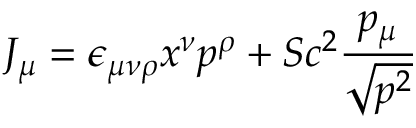Convert formula to latex. <formula><loc_0><loc_0><loc_500><loc_500>J _ { \mu } = \epsilon _ { \mu \nu \rho } x ^ { \nu } p ^ { \rho } + S c ^ { 2 } \frac { p _ { \mu } } { \sqrt { p ^ { 2 } } }</formula> 